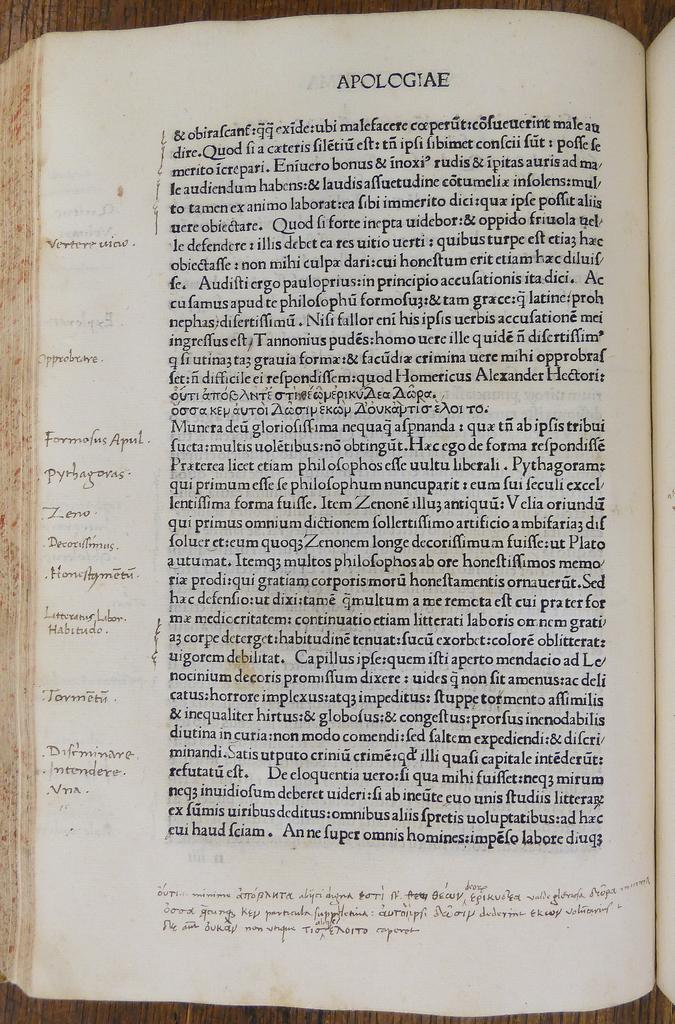Provide a one-sentence caption for the provided image. A book is opened to a page which is titled Apologiae. 